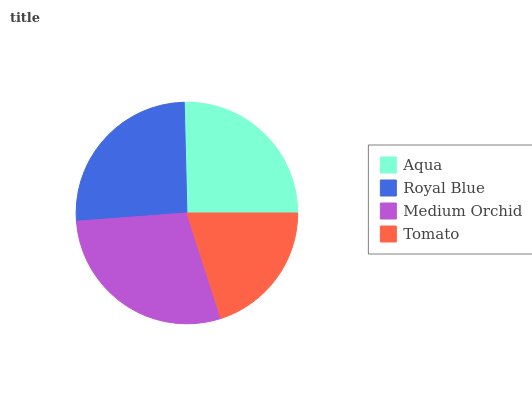Is Tomato the minimum?
Answer yes or no. Yes. Is Medium Orchid the maximum?
Answer yes or no. Yes. Is Royal Blue the minimum?
Answer yes or no. No. Is Royal Blue the maximum?
Answer yes or no. No. Is Royal Blue greater than Aqua?
Answer yes or no. Yes. Is Aqua less than Royal Blue?
Answer yes or no. Yes. Is Aqua greater than Royal Blue?
Answer yes or no. No. Is Royal Blue less than Aqua?
Answer yes or no. No. Is Royal Blue the high median?
Answer yes or no. Yes. Is Aqua the low median?
Answer yes or no. Yes. Is Medium Orchid the high median?
Answer yes or no. No. Is Royal Blue the low median?
Answer yes or no. No. 